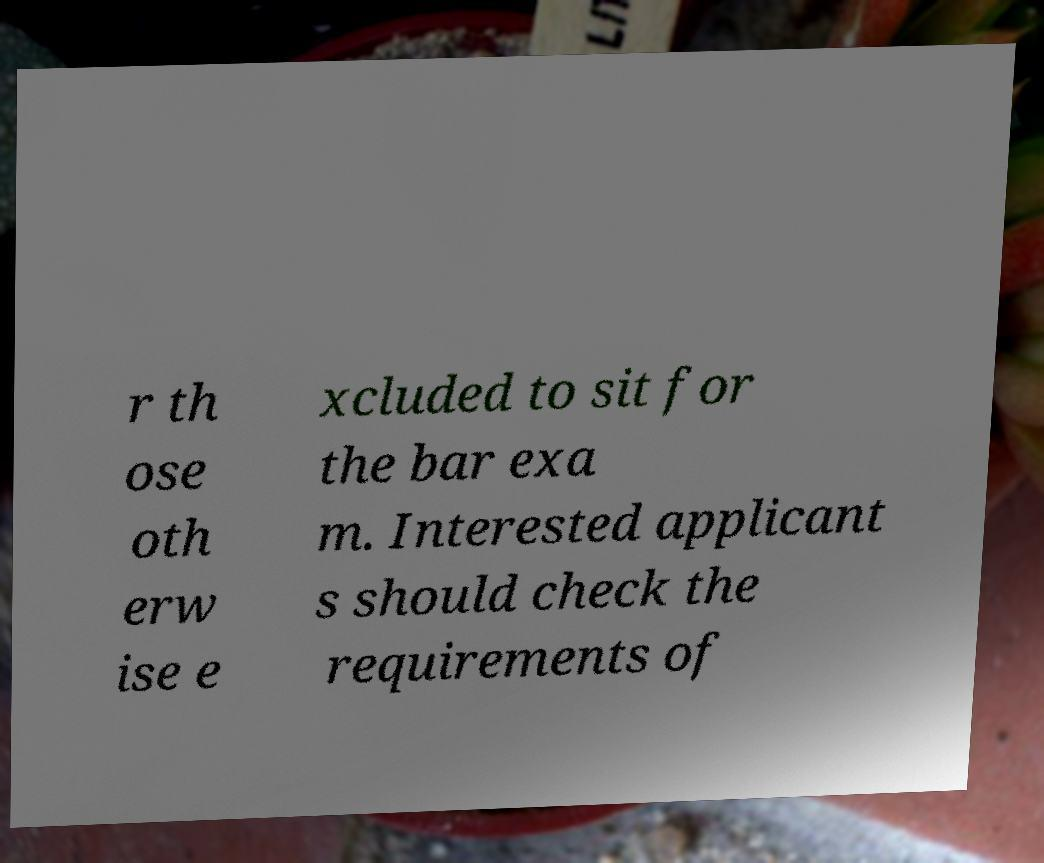Please read and relay the text visible in this image. What does it say? r th ose oth erw ise e xcluded to sit for the bar exa m. Interested applicant s should check the requirements of 